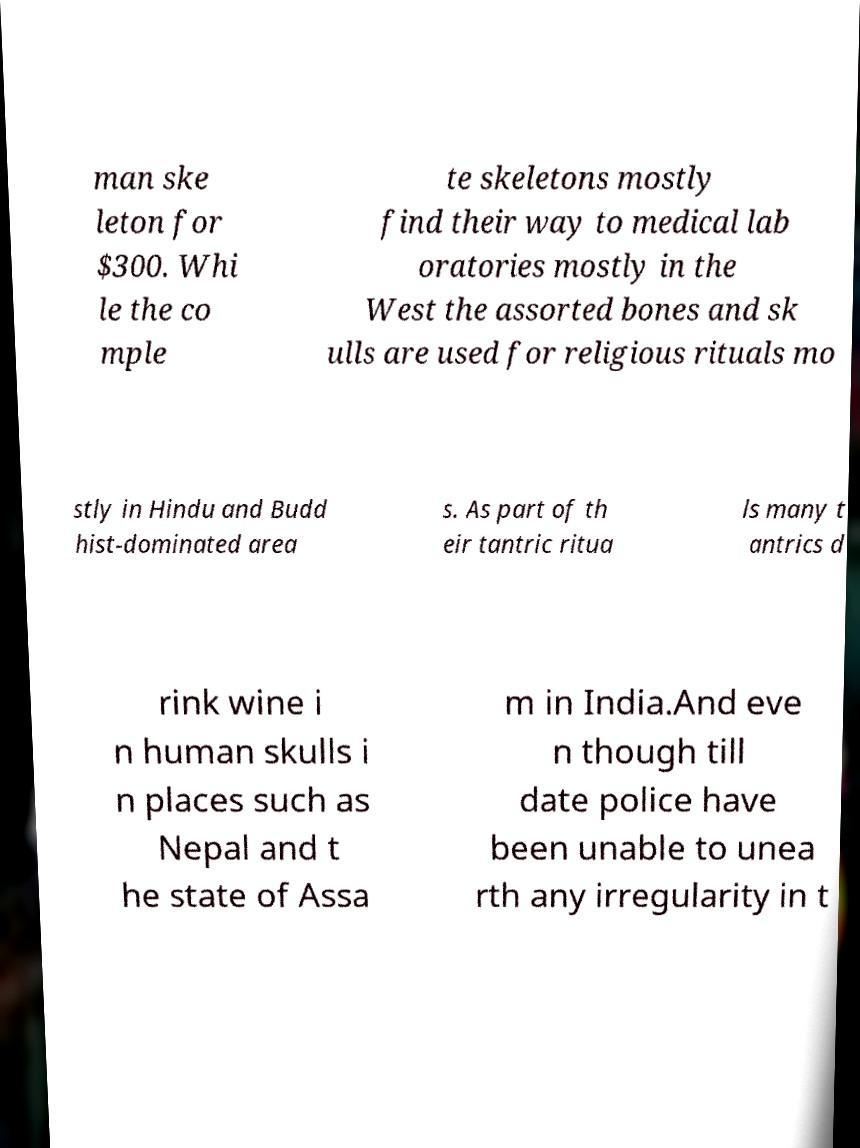For documentation purposes, I need the text within this image transcribed. Could you provide that? man ske leton for $300. Whi le the co mple te skeletons mostly find their way to medical lab oratories mostly in the West the assorted bones and sk ulls are used for religious rituals mo stly in Hindu and Budd hist-dominated area s. As part of th eir tantric ritua ls many t antrics d rink wine i n human skulls i n places such as Nepal and t he state of Assa m in India.And eve n though till date police have been unable to unea rth any irregularity in t 